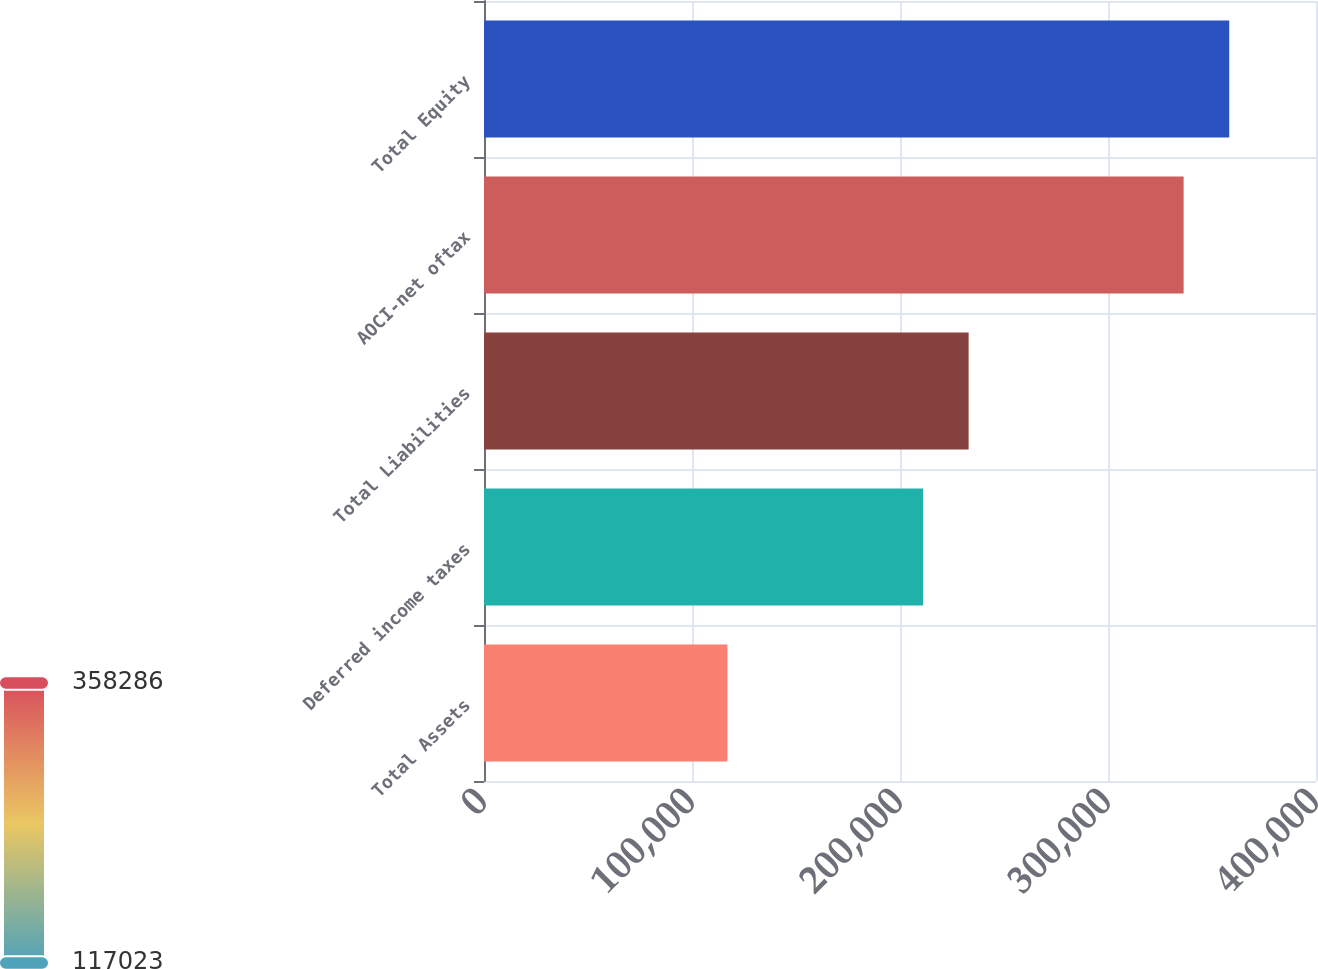<chart> <loc_0><loc_0><loc_500><loc_500><bar_chart><fcel>Total Assets<fcel>Deferred income taxes<fcel>Total Liabilities<fcel>AOCI-net oftax<fcel>Total Equity<nl><fcel>117023<fcel>211061<fcel>232994<fcel>336353<fcel>358286<nl></chart> 